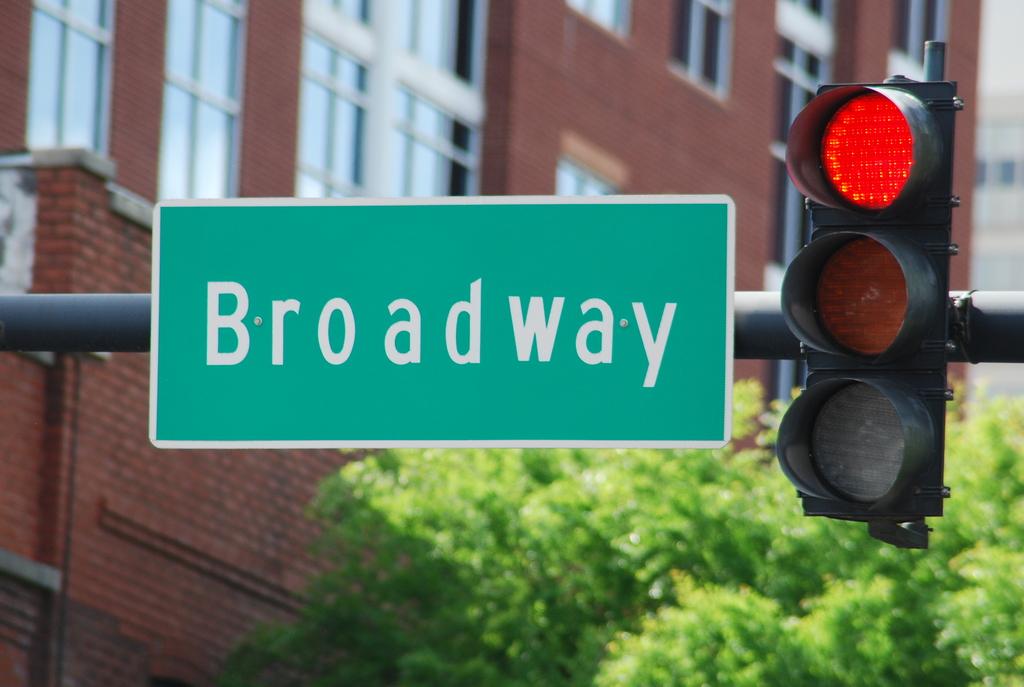What street are they at?
Your answer should be very brief. Broadway. 